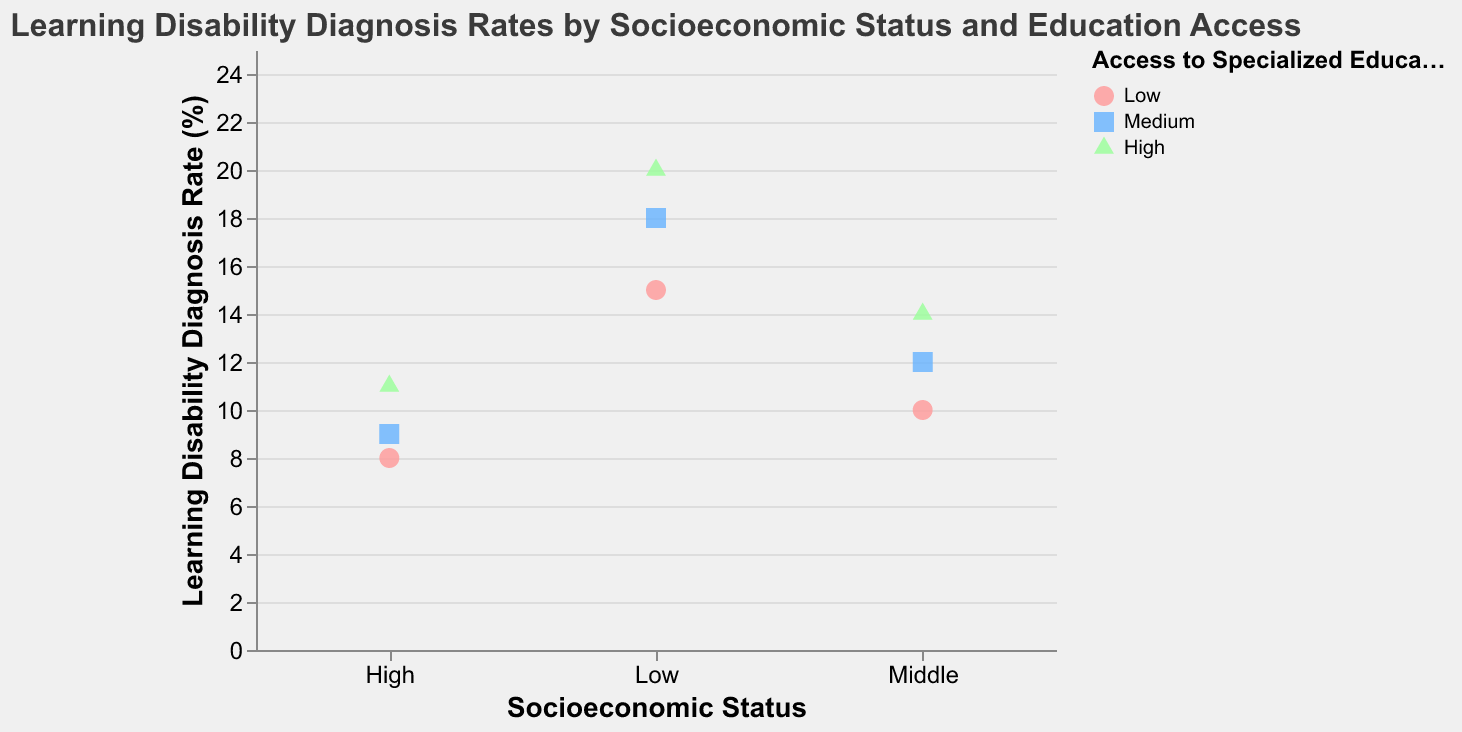What is the title of the plot? The title of the plot can be found at the top and usually provides a summary of what the plot is about which helps in quickly understanding the data presented. The title of this plot is "Learning Disability Diagnosis Rates by Socioeconomic Status and Education Access".
Answer: Learning Disability Diagnosis Rates by Socioeconomic Status and Education Access What axis represents the Socioeconomic Status? The axes in a plot represent different variables. The X-axis is the horizontal line at the bottom of the plot, representing the Socioeconomic Status.
Answer: X-axis Which color represents high access to specialized education programs? The colors in the legend denote different categories of Access to Specialized Education Programs. The colors and their corresponding categories are detailed in the encoding, where high access is marked with a green shade.
Answer: green How many data points have a diagnosis rate between 10% and 20%? To determine the number of points in this range, we look at the y-axis values. There are points at 10, 12, 14, 15, 18, and 20%, summing up to 6 points.
Answer: 6 Is there a consistent trend in diagnosis rates with increasing access to specialized education programs within each socioeconomic status? To identify trends, we observe the direction in which data points shift across categories. Within each socioeconomic group (Low, Middle, High), we see an increase in diagnosis rates as access moves from Low to High.
Answer: Yes Which socioeconomic group has the highest diagnosis rate at high access to specialized education programs? To find this, check the data points within the High access category for each socioeconomic status. The maximum value among these is for Low socioeconomic status at 20%.
Answer: Low What is the difference in diagnosis rates between Middle and High socioeconomic status for medium access to specialized education programs? From the plot, Middle socioeconomic status at Medium access has a diagnosis rate of 12% and High socioeconomic status at Medium access has a diagnosis rate of 9%. The difference is 12% - 9% = 3%.
Answer: 3% Which shape represents medium access to specialized education programs? The shapes corresponding to access levels can be found in the legend. Medium access is represented by a square.
Answer: square Are there any cases where higher socioeconomic status has a higher diagnosis rate than lower socioeconomic status within the same level of access to specialized education programs? To evaluate this, we compare the diagnosis rates across each access level. The only case where this occurs is at High access, where High socioeconomic status (11%) is less than Low socioeconomic status (20%).
Answer: No What's the average diagnosis rate for the Low socioeconomic status group? Calculate the average using the values for Low socioeconomic status: (15 + 18 + 20) / 3 = 53 / 3 ≈ 17.7. So the average diagnosis rate for the Low socioeconomic status group is approximately 17.7%.
Answer: 17.7 